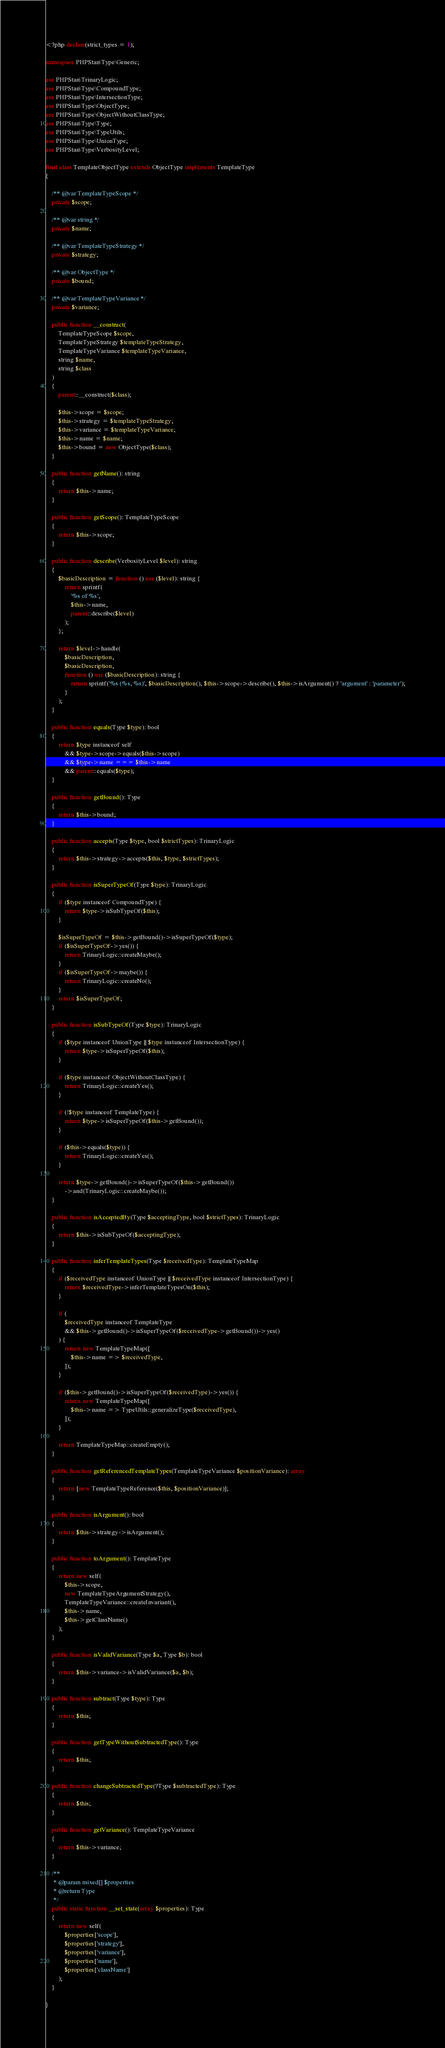<code> <loc_0><loc_0><loc_500><loc_500><_PHP_><?php declare(strict_types = 1);

namespace PHPStan\Type\Generic;

use PHPStan\TrinaryLogic;
use PHPStan\Type\CompoundType;
use PHPStan\Type\IntersectionType;
use PHPStan\Type\ObjectType;
use PHPStan\Type\ObjectWithoutClassType;
use PHPStan\Type\Type;
use PHPStan\Type\TypeUtils;
use PHPStan\Type\UnionType;
use PHPStan\Type\VerbosityLevel;

final class TemplateObjectType extends ObjectType implements TemplateType
{

	/** @var TemplateTypeScope */
	private $scope;

	/** @var string */
	private $name;

	/** @var TemplateTypeStrategy */
	private $strategy;

	/** @var ObjectType */
	private $bound;

	/** @var TemplateTypeVariance */
	private $variance;

	public function __construct(
		TemplateTypeScope $scope,
		TemplateTypeStrategy $templateTypeStrategy,
		TemplateTypeVariance $templateTypeVariance,
		string $name,
		string $class
	)
	{
		parent::__construct($class);

		$this->scope = $scope;
		$this->strategy = $templateTypeStrategy;
		$this->variance = $templateTypeVariance;
		$this->name = $name;
		$this->bound = new ObjectType($class);
	}

	public function getName(): string
	{
		return $this->name;
	}

	public function getScope(): TemplateTypeScope
	{
		return $this->scope;
	}

	public function describe(VerbosityLevel $level): string
	{
		$basicDescription = function () use ($level): string {
			return sprintf(
				'%s of %s',
				$this->name,
				parent::describe($level)
			);
		};

		return $level->handle(
			$basicDescription,
			$basicDescription,
			function () use ($basicDescription): string {
				return sprintf('%s (%s, %s)', $basicDescription(), $this->scope->describe(), $this->isArgument() ? 'argument' : 'parameter');
			}
		);
	}

	public function equals(Type $type): bool
	{
		return $type instanceof self
			&& $type->scope->equals($this->scope)
			&& $type->name === $this->name
			&& parent::equals($type);
	}

	public function getBound(): Type
	{
		return $this->bound;
	}

	public function accepts(Type $type, bool $strictTypes): TrinaryLogic
	{
		return $this->strategy->accepts($this, $type, $strictTypes);
	}

	public function isSuperTypeOf(Type $type): TrinaryLogic
	{
		if ($type instanceof CompoundType) {
			return $type->isSubTypeOf($this);
		}

		$isSuperTypeOf = $this->getBound()->isSuperTypeOf($type);
		if ($isSuperTypeOf->yes()) {
			return TrinaryLogic::createMaybe();
		}
		if ($isSuperTypeOf->maybe()) {
			return TrinaryLogic::createNo();
		}
		return $isSuperTypeOf;
	}

	public function isSubTypeOf(Type $type): TrinaryLogic
	{
		if ($type instanceof UnionType || $type instanceof IntersectionType) {
			return $type->isSuperTypeOf($this);
		}

		if ($type instanceof ObjectWithoutClassType) {
			return TrinaryLogic::createYes();
		}

		if (!$type instanceof TemplateType) {
			return $type->isSuperTypeOf($this->getBound());
		}

		if ($this->equals($type)) {
			return TrinaryLogic::createYes();
		}

		return $type->getBound()->isSuperTypeOf($this->getBound())
			->and(TrinaryLogic::createMaybe());
	}

	public function isAcceptedBy(Type $acceptingType, bool $strictTypes): TrinaryLogic
	{
		return $this->isSubTypeOf($acceptingType);
	}

	public function inferTemplateTypes(Type $receivedType): TemplateTypeMap
	{
		if ($receivedType instanceof UnionType || $receivedType instanceof IntersectionType) {
			return $receivedType->inferTemplateTypesOn($this);
		}

		if (
			$receivedType instanceof TemplateType
			&& $this->getBound()->isSuperTypeOf($receivedType->getBound())->yes()
		) {
			return new TemplateTypeMap([
				$this->name => $receivedType,
			]);
		}

		if ($this->getBound()->isSuperTypeOf($receivedType)->yes()) {
			return new TemplateTypeMap([
				$this->name => TypeUtils::generalizeType($receivedType),
			]);
		}

		return TemplateTypeMap::createEmpty();
	}

	public function getReferencedTemplateTypes(TemplateTypeVariance $positionVariance): array
	{
		return [new TemplateTypeReference($this, $positionVariance)];
	}

	public function isArgument(): bool
	{
		return $this->strategy->isArgument();
	}

	public function toArgument(): TemplateType
	{
		return new self(
			$this->scope,
			new TemplateTypeArgumentStrategy(),
			TemplateTypeVariance::createInvariant(),
			$this->name,
			$this->getClassName()
		);
	}

	public function isValidVariance(Type $a, Type $b): bool
	{
		return $this->variance->isValidVariance($a, $b);
	}

	public function subtract(Type $type): Type
	{
		return $this;
	}

	public function getTypeWithoutSubtractedType(): Type
	{
		return $this;
	}

	public function changeSubtractedType(?Type $subtractedType): Type
	{
		return $this;
	}

	public function getVariance(): TemplateTypeVariance
	{
		return $this->variance;
	}

	/**
	 * @param mixed[] $properties
	 * @return Type
	 */
	public static function __set_state(array $properties): Type
	{
		return new self(
			$properties['scope'],
			$properties['strategy'],
			$properties['variance'],
			$properties['name'],
			$properties['className']
		);
	}

}
</code> 